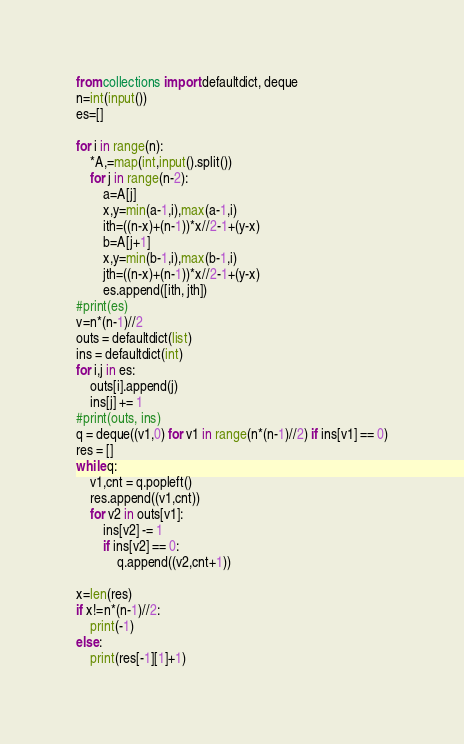<code> <loc_0><loc_0><loc_500><loc_500><_Python_>from collections import defaultdict, deque
n=int(input())
es=[]

for i in range(n):
    *A,=map(int,input().split())
    for j in range(n-2):
        a=A[j]
        x,y=min(a-1,i),max(a-1,i)
        ith=((n-x)+(n-1))*x//2-1+(y-x)
        b=A[j+1]
        x,y=min(b-1,i),max(b-1,i)
        jth=((n-x)+(n-1))*x//2-1+(y-x)
        es.append([ith, jth])
#print(es)
v=n*(n-1)//2
outs = defaultdict(list)
ins = defaultdict(int)
for i,j in es:
    outs[i].append(j)
    ins[j] += 1
#print(outs, ins)
q = deque((v1,0) for v1 in range(n*(n-1)//2) if ins[v1] == 0)
res = []
while q:
    v1,cnt = q.popleft()
    res.append((v1,cnt))
    for v2 in outs[v1]:
        ins[v2] -= 1
        if ins[v2] == 0:
            q.append((v2,cnt+1))

x=len(res)
if x!=n*(n-1)//2:
    print(-1)
else:
    print(res[-1][1]+1)</code> 